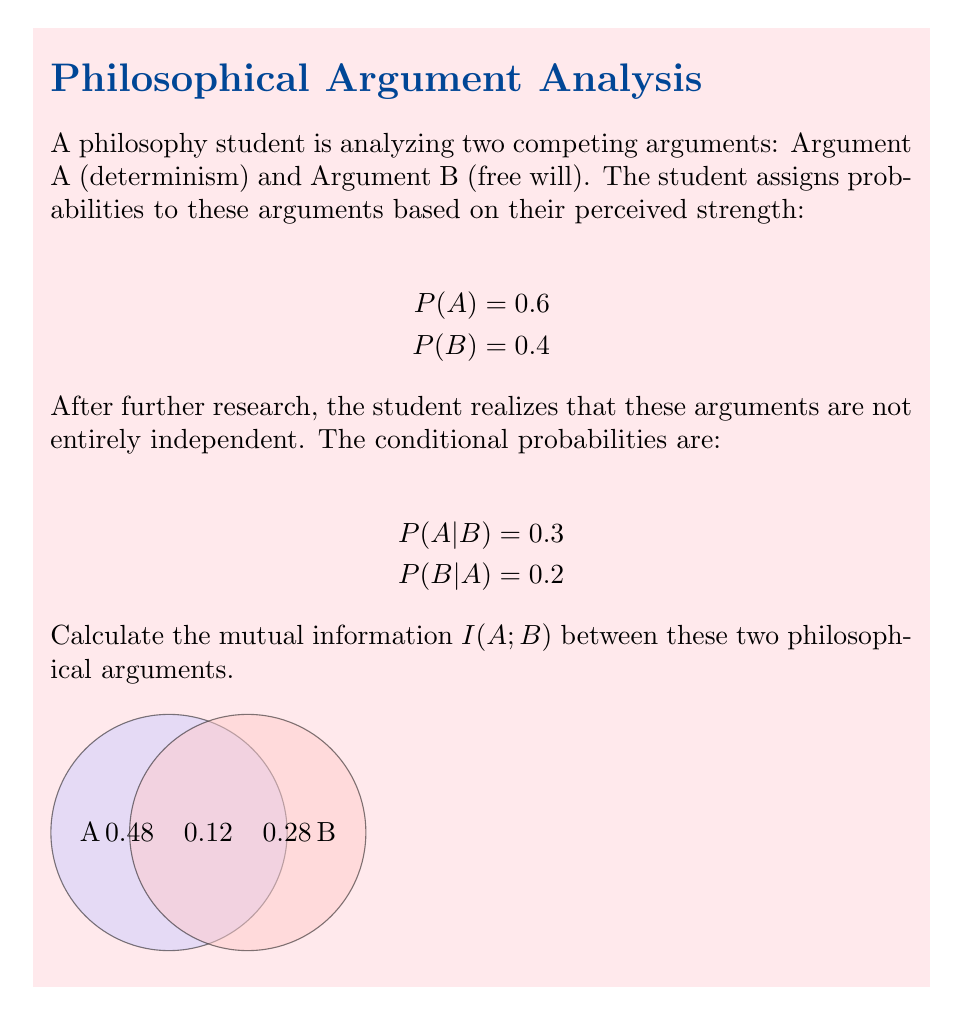Solve this math problem. To calculate the mutual information I(A;B), we'll follow these steps:

1) First, we need to calculate P(A,B) using the given information:
   P(A,B) = P(A) * P(B|A) = 0.6 * 0.2 = 0.12

2) Now we can calculate P(A,¬B) and P(¬A,B):
   P(A,¬B) = P(A) - P(A,B) = 0.6 - 0.12 = 0.48
   P(¬A,B) = P(B) - P(A,B) = 0.4 - 0.12 = 0.28

3) The mutual information formula is:
   $$I(A;B) = \sum_{a \in A} \sum_{b \in B} P(a,b) \log_2 \frac{P(a,b)}{P(a)P(b)}$$

4) Let's calculate each term:
   For (A,B):   0.12 * log2(0.12 / (0.6 * 0.4)) = 0.12 * log2(0.5) = -0.06021
   For (A,¬B):  0.48 * log2(0.48 / (0.6 * 0.6)) = 0.48 * log2(1.3333) = 0.20217
   For (¬A,B):  0.28 * log2(0.28 / (0.4 * 0.4)) = 0.28 * log2(1.75) = 0.36442
   For (¬A,¬B): 0.12 * log2(0.12 / (0.4 * 0.6)) = 0.12 * log2(0.5) = -0.06021

5) Sum all these terms:
   I(A;B) = -0.06021 + 0.20217 + 0.36442 - 0.06021 = 0.44617 bits

This value represents the amount of information shared between the two philosophical arguments.
Answer: 0.44617 bits 